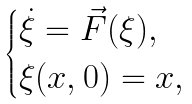<formula> <loc_0><loc_0><loc_500><loc_500>\begin{cases} \dot { \xi } = \vec { F } ( \xi ) , & \text { } \\ \xi ( x , 0 ) = x , & \text { } \end{cases}</formula> 